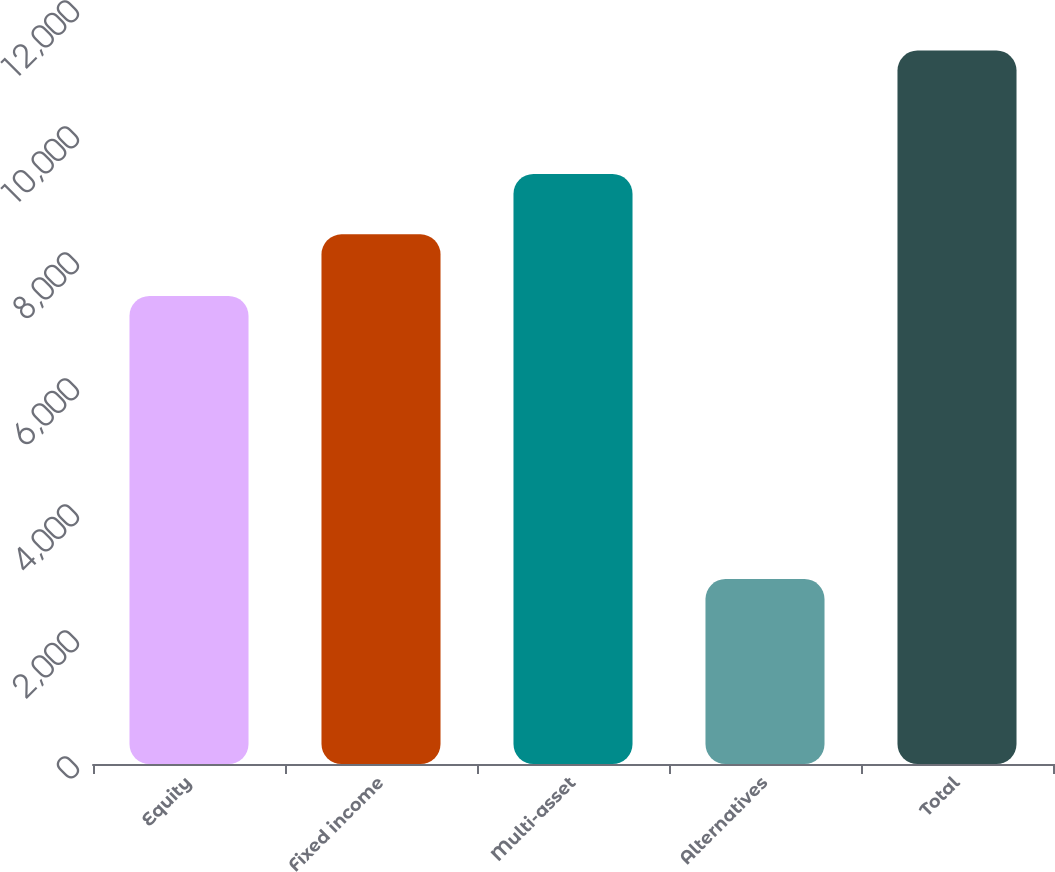Convert chart to OTSL. <chart><loc_0><loc_0><loc_500><loc_500><bar_chart><fcel>Equity<fcel>Fixed income<fcel>Multi-asset<fcel>Alternatives<fcel>Total<nl><fcel>7429<fcel>8407<fcel>9367<fcel>2935<fcel>11324<nl></chart> 